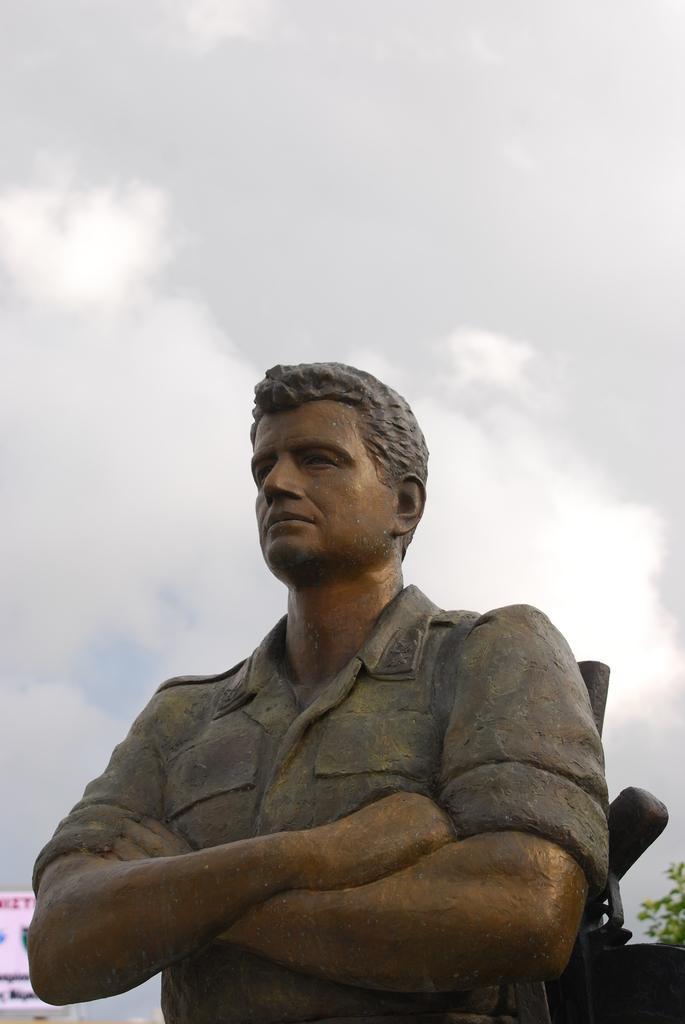Can you describe this image briefly? In this image, we can see a statue of a person. In the background, we can see board, tree and cloudy sky. 